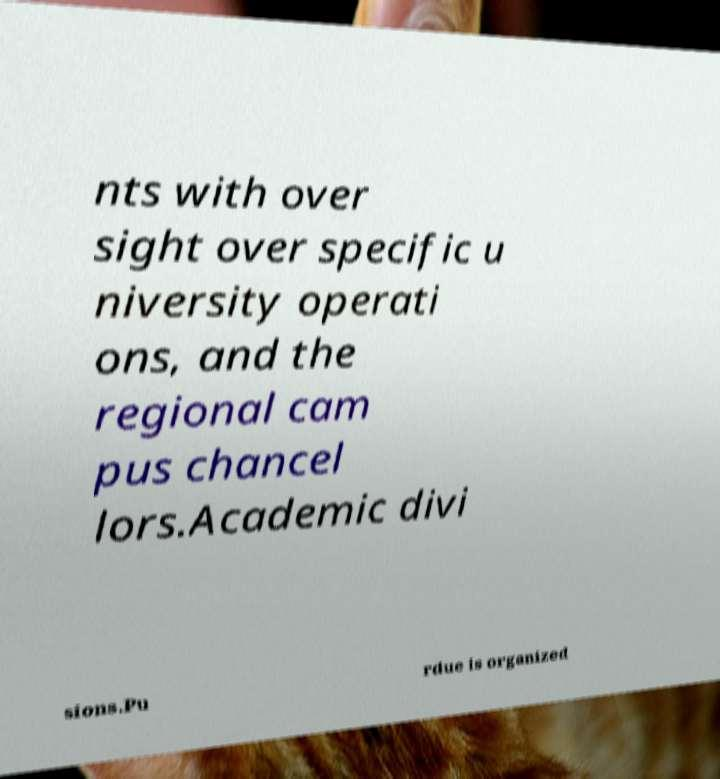Could you assist in decoding the text presented in this image and type it out clearly? nts with over sight over specific u niversity operati ons, and the regional cam pus chancel lors.Academic divi sions.Pu rdue is organized 